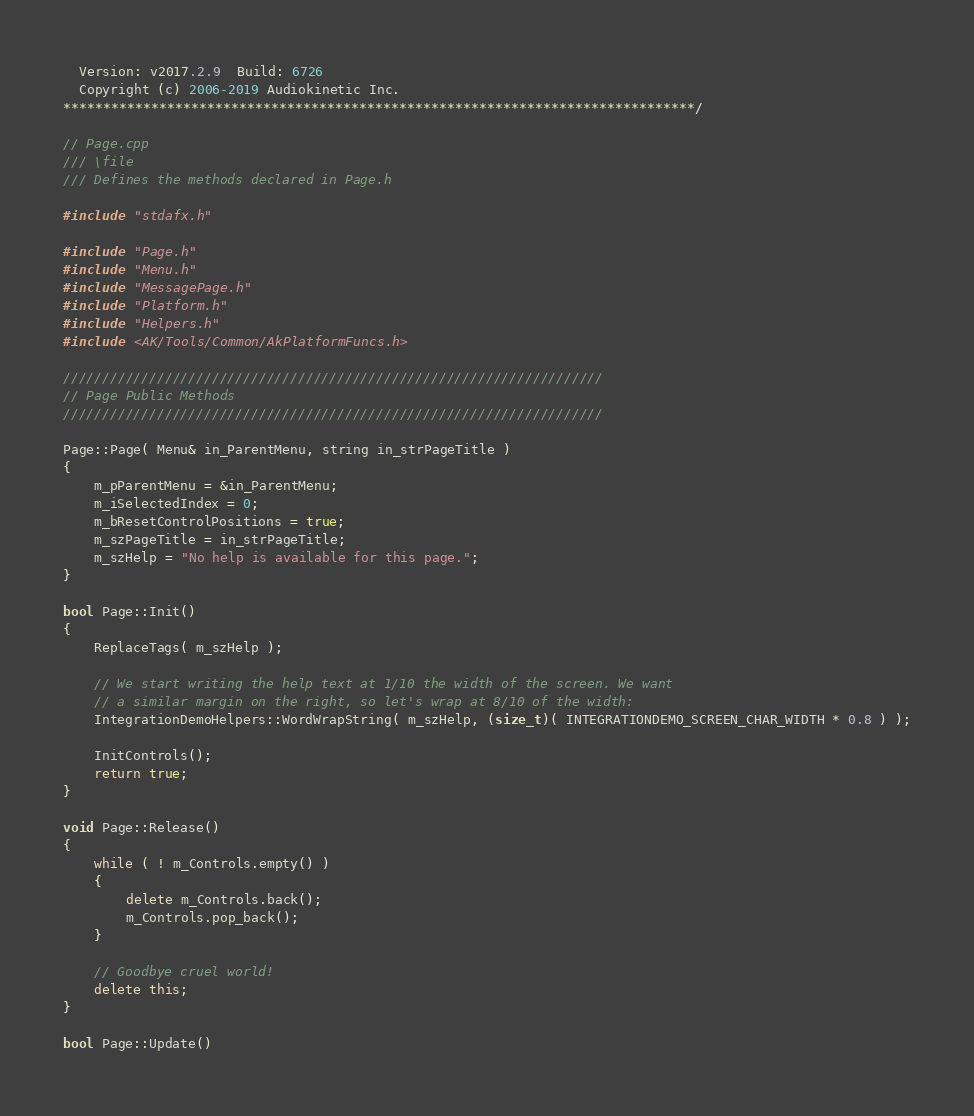Convert code to text. <code><loc_0><loc_0><loc_500><loc_500><_C++_>  Version: v2017.2.9  Build: 6726
  Copyright (c) 2006-2019 Audiokinetic Inc.
*******************************************************************************/

// Page.cpp
/// \file 
/// Defines the methods declared in Page.h

#include "stdafx.h"

#include "Page.h"
#include "Menu.h"
#include "MessagePage.h"
#include "Platform.h"
#include "Helpers.h"
#include <AK/Tools/Common/AkPlatformFuncs.h>

/////////////////////////////////////////////////////////////////////
// Page Public Methods
/////////////////////////////////////////////////////////////////////

Page::Page( Menu& in_ParentMenu, string in_strPageTitle )
{
	m_pParentMenu = &in_ParentMenu;
	m_iSelectedIndex = 0;
	m_bResetControlPositions = true;
	m_szPageTitle = in_strPageTitle;
	m_szHelp = "No help is available for this page.";
}

bool Page::Init()
{
	ReplaceTags( m_szHelp );

	// We start writing the help text at 1/10 the width of the screen. We want
	// a similar margin on the right, so let's wrap at 8/10 of the width:
	IntegrationDemoHelpers::WordWrapString( m_szHelp, (size_t)( INTEGRATIONDEMO_SCREEN_CHAR_WIDTH * 0.8 ) );

	InitControls();
	return true;
}

void Page::Release()
{
	while ( ! m_Controls.empty() )
	{
		delete m_Controls.back();
		m_Controls.pop_back();
	}

	// Goodbye cruel world!
	delete this;
}

bool Page::Update()</code> 